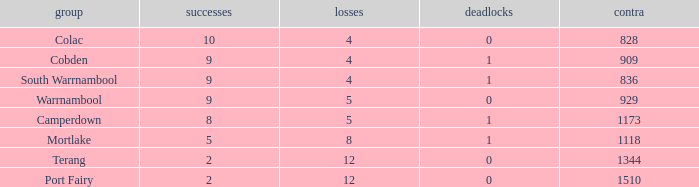What is the sum of losses for Against values over 1510? None. 